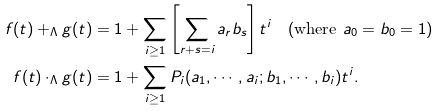<formula> <loc_0><loc_0><loc_500><loc_500>f ( t ) + _ { \Lambda } g ( t ) & = 1 + \sum _ { i \geq 1 } \left [ \sum _ { r + s = i } a _ { r } b _ { s } \right ] t ^ { i } \quad ( \text {where } a _ { 0 } = b _ { 0 } = 1 ) \\ f ( t ) \cdot _ { \Lambda } g ( t ) & = 1 + \sum _ { i \geq 1 } P _ { i } ( a _ { 1 } , \cdots , a _ { i } ; b _ { 1 } , \cdots , b _ { i } ) t ^ { i } .</formula> 